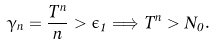Convert formula to latex. <formula><loc_0><loc_0><loc_500><loc_500>\gamma _ { n } = \frac { \bar { T } ^ { n } } { n } > \epsilon _ { 1 } \Longrightarrow \bar { T } ^ { n } > N _ { 0 } .</formula> 